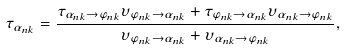Convert formula to latex. <formula><loc_0><loc_0><loc_500><loc_500>\tau _ { \alpha _ { n k } } = \frac { \tau _ { \alpha _ { n k } \rightarrow \varphi _ { n k } } \upsilon _ { \varphi _ { n k } \rightarrow \alpha _ { n k } } + \tau _ { \varphi _ { n k } \rightarrow \alpha _ { n k } } \upsilon _ { \alpha _ { n k } \rightarrow \varphi _ { n k } } } { \upsilon _ { \varphi _ { n k } \rightarrow \alpha _ { n k } } + \upsilon _ { \alpha _ { n k } \rightarrow \varphi _ { n k } } } ,</formula> 